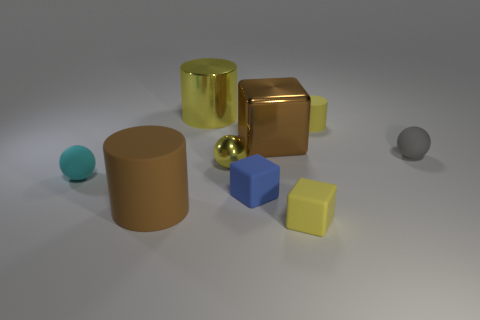Can you describe the objects in the image that have reflective surfaces? Certainly! In the image, there are two objects with reflective surfaces. One is a golden cube that has a highly polished surface reflecting the environment, and the other is a small golden sphere with a similar reflective quality. 